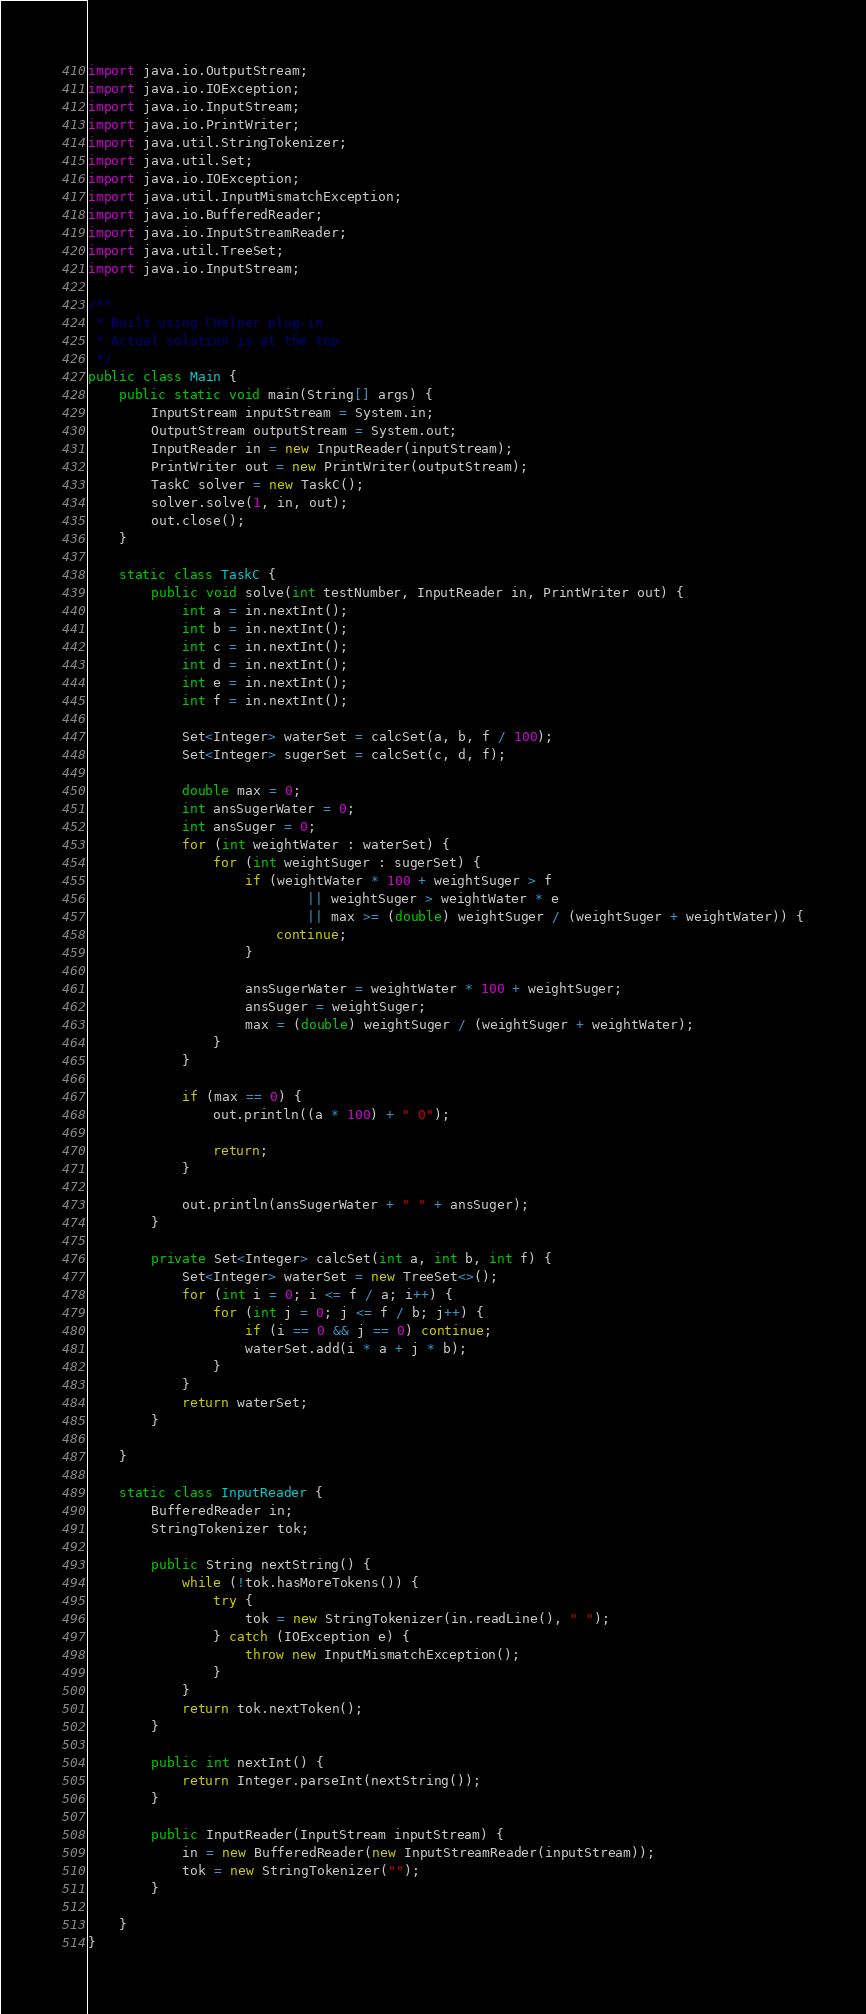Convert code to text. <code><loc_0><loc_0><loc_500><loc_500><_Java_>import java.io.OutputStream;
import java.io.IOException;
import java.io.InputStream;
import java.io.PrintWriter;
import java.util.StringTokenizer;
import java.util.Set;
import java.io.IOException;
import java.util.InputMismatchException;
import java.io.BufferedReader;
import java.io.InputStreamReader;
import java.util.TreeSet;
import java.io.InputStream;

/**
 * Built using CHelper plug-in
 * Actual solution is at the top
 */
public class Main {
    public static void main(String[] args) {
        InputStream inputStream = System.in;
        OutputStream outputStream = System.out;
        InputReader in = new InputReader(inputStream);
        PrintWriter out = new PrintWriter(outputStream);
        TaskC solver = new TaskC();
        solver.solve(1, in, out);
        out.close();
    }

    static class TaskC {
        public void solve(int testNumber, InputReader in, PrintWriter out) {
            int a = in.nextInt();
            int b = in.nextInt();
            int c = in.nextInt();
            int d = in.nextInt();
            int e = in.nextInt();
            int f = in.nextInt();

            Set<Integer> waterSet = calcSet(a, b, f / 100);
            Set<Integer> sugerSet = calcSet(c, d, f);

            double max = 0;
            int ansSugerWater = 0;
            int ansSuger = 0;
            for (int weightWater : waterSet) {
                for (int weightSuger : sugerSet) {
                    if (weightWater * 100 + weightSuger > f
                            || weightSuger > weightWater * e
                            || max >= (double) weightSuger / (weightSuger + weightWater)) {
                        continue;
                    }

                    ansSugerWater = weightWater * 100 + weightSuger;
                    ansSuger = weightSuger;
                    max = (double) weightSuger / (weightSuger + weightWater);
                }
            }

            if (max == 0) {
                out.println((a * 100) + " 0");

                return;
            }

            out.println(ansSugerWater + " " + ansSuger);
        }

        private Set<Integer> calcSet(int a, int b, int f) {
            Set<Integer> waterSet = new TreeSet<>();
            for (int i = 0; i <= f / a; i++) {
                for (int j = 0; j <= f / b; j++) {
                    if (i == 0 && j == 0) continue;
                    waterSet.add(i * a + j * b);
                }
            }
            return waterSet;
        }

    }

    static class InputReader {
        BufferedReader in;
        StringTokenizer tok;

        public String nextString() {
            while (!tok.hasMoreTokens()) {
                try {
                    tok = new StringTokenizer(in.readLine(), " ");
                } catch (IOException e) {
                    throw new InputMismatchException();
                }
            }
            return tok.nextToken();
        }

        public int nextInt() {
            return Integer.parseInt(nextString());
        }

        public InputReader(InputStream inputStream) {
            in = new BufferedReader(new InputStreamReader(inputStream));
            tok = new StringTokenizer("");
        }

    }
}

</code> 